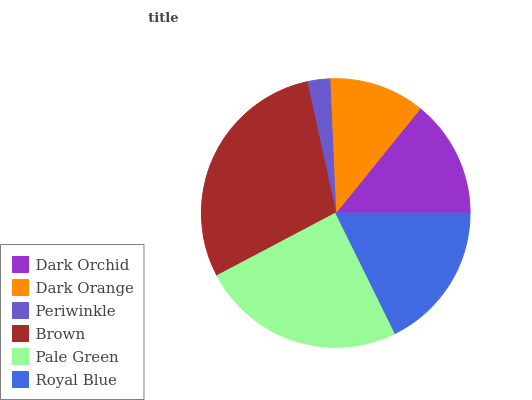Is Periwinkle the minimum?
Answer yes or no. Yes. Is Brown the maximum?
Answer yes or no. Yes. Is Dark Orange the minimum?
Answer yes or no. No. Is Dark Orange the maximum?
Answer yes or no. No. Is Dark Orchid greater than Dark Orange?
Answer yes or no. Yes. Is Dark Orange less than Dark Orchid?
Answer yes or no. Yes. Is Dark Orange greater than Dark Orchid?
Answer yes or no. No. Is Dark Orchid less than Dark Orange?
Answer yes or no. No. Is Royal Blue the high median?
Answer yes or no. Yes. Is Dark Orchid the low median?
Answer yes or no. Yes. Is Brown the high median?
Answer yes or no. No. Is Brown the low median?
Answer yes or no. No. 